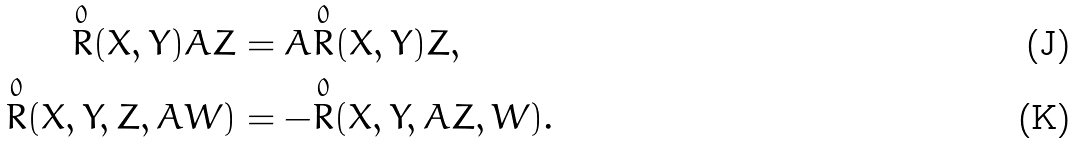<formula> <loc_0><loc_0><loc_500><loc_500>\overset { 0 } { R } ( X , Y ) A Z & = A \overset { 0 } { R } ( X , Y ) Z , \\ \overset { 0 } { R } ( X , Y , Z , A W ) & = - \overset { 0 } { R } ( X , Y , A Z , W ) .</formula> 